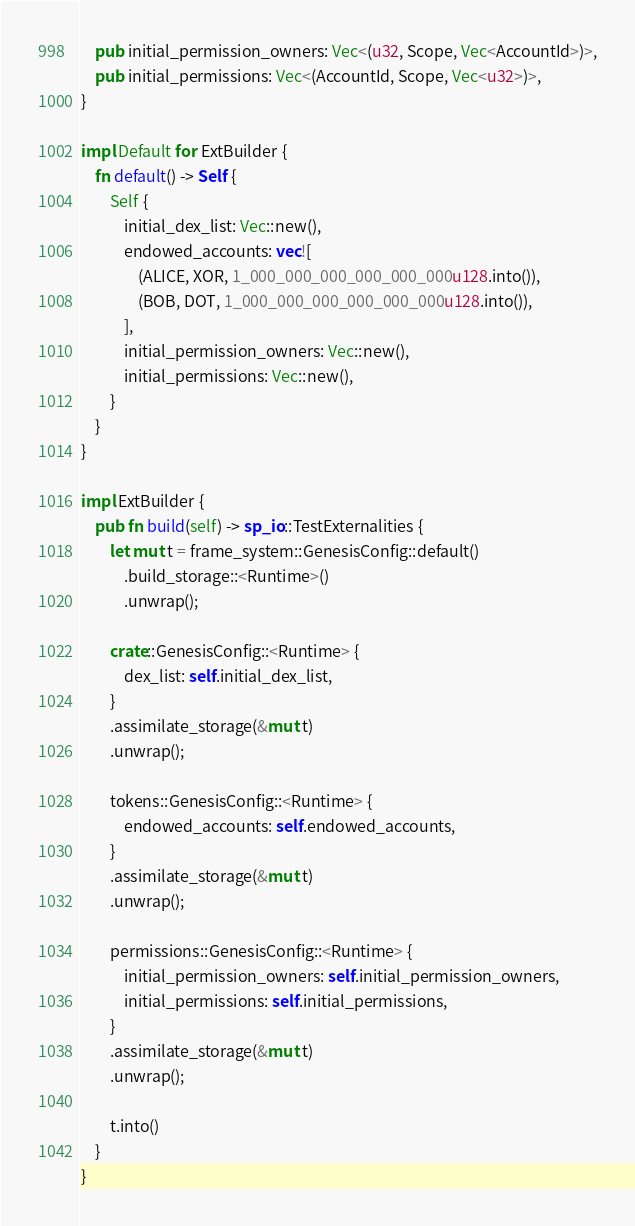<code> <loc_0><loc_0><loc_500><loc_500><_Rust_>    pub initial_permission_owners: Vec<(u32, Scope, Vec<AccountId>)>,
    pub initial_permissions: Vec<(AccountId, Scope, Vec<u32>)>,
}

impl Default for ExtBuilder {
    fn default() -> Self {
        Self {
            initial_dex_list: Vec::new(),
            endowed_accounts: vec![
                (ALICE, XOR, 1_000_000_000_000_000_000u128.into()),
                (BOB, DOT, 1_000_000_000_000_000_000u128.into()),
            ],
            initial_permission_owners: Vec::new(),
            initial_permissions: Vec::new(),
        }
    }
}

impl ExtBuilder {
    pub fn build(self) -> sp_io::TestExternalities {
        let mut t = frame_system::GenesisConfig::default()
            .build_storage::<Runtime>()
            .unwrap();

        crate::GenesisConfig::<Runtime> {
            dex_list: self.initial_dex_list,
        }
        .assimilate_storage(&mut t)
        .unwrap();

        tokens::GenesisConfig::<Runtime> {
            endowed_accounts: self.endowed_accounts,
        }
        .assimilate_storage(&mut t)
        .unwrap();

        permissions::GenesisConfig::<Runtime> {
            initial_permission_owners: self.initial_permission_owners,
            initial_permissions: self.initial_permissions,
        }
        .assimilate_storage(&mut t)
        .unwrap();

        t.into()
    }
}
</code> 